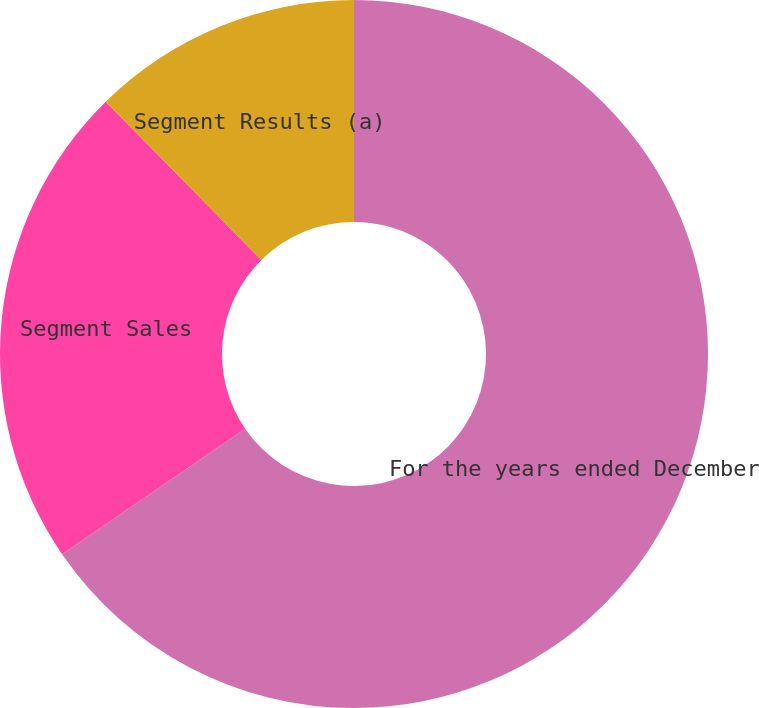<chart> <loc_0><loc_0><loc_500><loc_500><pie_chart><fcel>For the years ended December<fcel>Segment Sales<fcel>Segment Results (a)<nl><fcel>65.43%<fcel>22.2%<fcel>12.37%<nl></chart> 